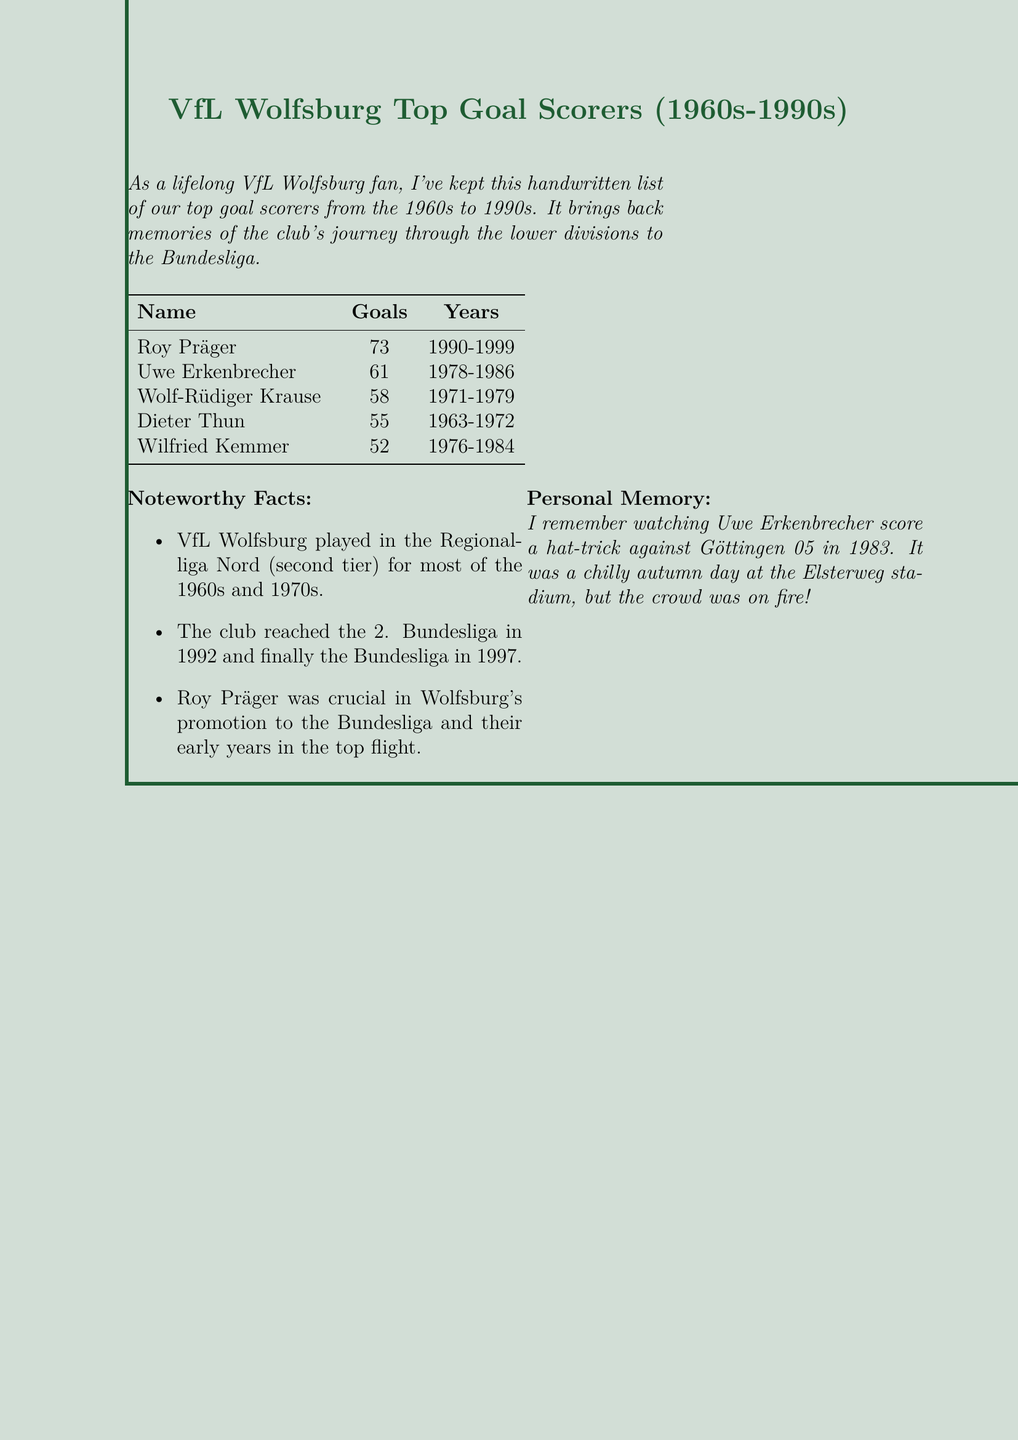What is the title of the document? The title is prominently displayed at the top of the document, which lists the topic covered.
Answer: VfL Wolfsburg Top Goal Scorers (1960s-1990s) Who is the top goal scorer listed? The top goal scorer is mentioned first in the table of goal scorers and has the highest recorded goals.
Answer: Roy Präger How many goals did Uwe Erkenbrecher score? Uwe Erkenbrecher's total goals are provided next to his name in the document.
Answer: 61 In what years did Dieter Thun play? The years played by Dieter Thun are specified in the same row as his name in the goal scorers table.
Answer: 1963-1972 What tier did VfL Wolfsburg play in during most of the 1960s? The document mentions the division the club was in for the majority of that time.
Answer: Regionalliga Nord How many goals does Wilfried Kemmer have? The document specifies the goal count for each player in the table format.
Answer: 52 What notable achievement does Roy Präger have? The document includes special facts about Roy Präger's impact on the club's progress.
Answer: Crucial in promotion to the Bundesliga What personal memory is mentioned in the document? A specific event from the author's memories related to a goal scorer is noted in the personal memory section.
Answer: Watching Uwe Erkenbrecher score a hat-trick against Göttingen 05 in 1983 